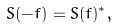<formula> <loc_0><loc_0><loc_500><loc_500>S ( - f ) = S ( f ) ^ { * } ,</formula> 